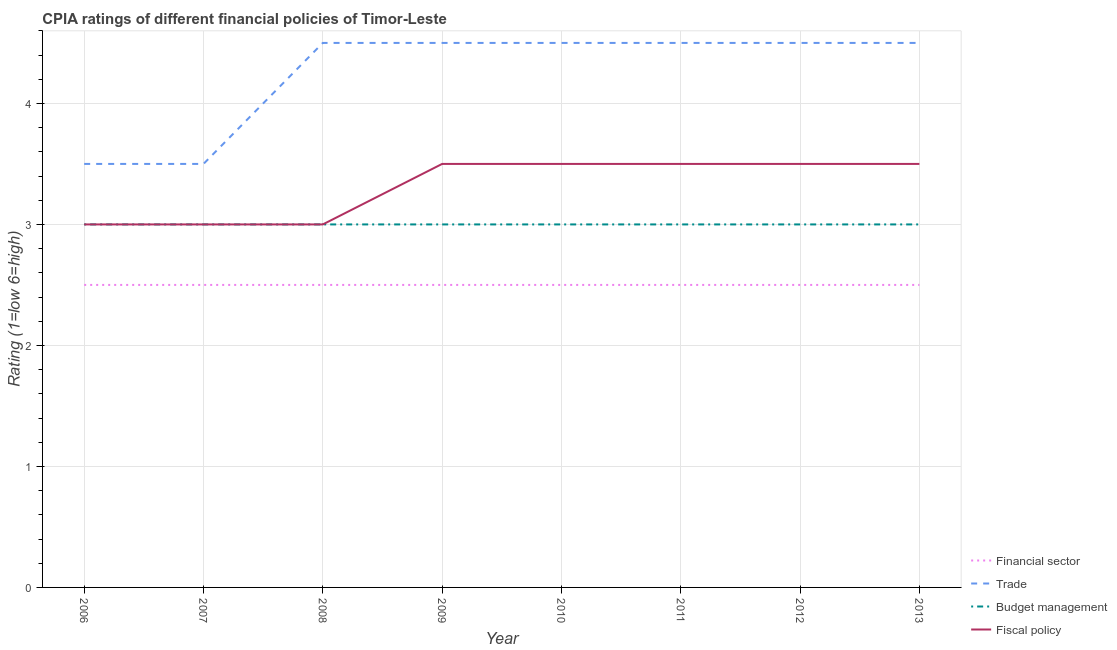How many different coloured lines are there?
Make the answer very short. 4. What is the cpia rating of financial sector in 2013?
Keep it short and to the point. 2.5. Across all years, what is the maximum cpia rating of budget management?
Your response must be concise. 3. Across all years, what is the minimum cpia rating of trade?
Your response must be concise. 3.5. In which year was the cpia rating of fiscal policy minimum?
Your answer should be very brief. 2006. What is the total cpia rating of financial sector in the graph?
Provide a succinct answer. 20. What is the average cpia rating of trade per year?
Offer a very short reply. 4.25. In the year 2012, what is the difference between the cpia rating of budget management and cpia rating of trade?
Offer a terse response. -1.5. What is the ratio of the cpia rating of budget management in 2008 to that in 2009?
Ensure brevity in your answer.  1. Is the cpia rating of financial sector in 2010 less than that in 2012?
Keep it short and to the point. No. Is the difference between the cpia rating of fiscal policy in 2006 and 2012 greater than the difference between the cpia rating of financial sector in 2006 and 2012?
Your answer should be compact. No. In how many years, is the cpia rating of financial sector greater than the average cpia rating of financial sector taken over all years?
Offer a terse response. 0. Is the sum of the cpia rating of budget management in 2008 and 2013 greater than the maximum cpia rating of financial sector across all years?
Your response must be concise. Yes. Is it the case that in every year, the sum of the cpia rating of budget management and cpia rating of financial sector is greater than the sum of cpia rating of trade and cpia rating of fiscal policy?
Make the answer very short. Yes. Does the cpia rating of budget management monotonically increase over the years?
Provide a succinct answer. No. Is the cpia rating of financial sector strictly less than the cpia rating of budget management over the years?
Ensure brevity in your answer.  Yes. How many lines are there?
Provide a succinct answer. 4. What is the difference between two consecutive major ticks on the Y-axis?
Your answer should be very brief. 1. Are the values on the major ticks of Y-axis written in scientific E-notation?
Your response must be concise. No. Does the graph contain grids?
Offer a terse response. Yes. How are the legend labels stacked?
Keep it short and to the point. Vertical. What is the title of the graph?
Ensure brevity in your answer.  CPIA ratings of different financial policies of Timor-Leste. What is the label or title of the X-axis?
Offer a terse response. Year. What is the Rating (1=low 6=high) in Budget management in 2007?
Offer a terse response. 3. What is the Rating (1=low 6=high) of Fiscal policy in 2007?
Keep it short and to the point. 3. What is the Rating (1=low 6=high) in Financial sector in 2008?
Make the answer very short. 2.5. What is the Rating (1=low 6=high) of Budget management in 2008?
Provide a short and direct response. 3. What is the Rating (1=low 6=high) in Financial sector in 2009?
Make the answer very short. 2.5. What is the Rating (1=low 6=high) in Budget management in 2009?
Your answer should be compact. 3. What is the Rating (1=low 6=high) in Fiscal policy in 2009?
Make the answer very short. 3.5. What is the Rating (1=low 6=high) in Fiscal policy in 2010?
Your answer should be compact. 3.5. What is the Rating (1=low 6=high) in Financial sector in 2011?
Offer a terse response. 2.5. What is the Rating (1=low 6=high) in Trade in 2011?
Your answer should be compact. 4.5. What is the Rating (1=low 6=high) of Fiscal policy in 2011?
Your response must be concise. 3.5. What is the Rating (1=low 6=high) in Financial sector in 2012?
Keep it short and to the point. 2.5. What is the Rating (1=low 6=high) in Trade in 2012?
Give a very brief answer. 4.5. What is the Rating (1=low 6=high) of Fiscal policy in 2012?
Your answer should be compact. 3.5. What is the Rating (1=low 6=high) of Budget management in 2013?
Give a very brief answer. 3. Across all years, what is the maximum Rating (1=low 6=high) of Financial sector?
Ensure brevity in your answer.  2.5. Across all years, what is the maximum Rating (1=low 6=high) in Budget management?
Offer a very short reply. 3. Across all years, what is the maximum Rating (1=low 6=high) of Fiscal policy?
Offer a very short reply. 3.5. Across all years, what is the minimum Rating (1=low 6=high) in Trade?
Make the answer very short. 3.5. Across all years, what is the minimum Rating (1=low 6=high) of Budget management?
Keep it short and to the point. 3. What is the total Rating (1=low 6=high) of Budget management in the graph?
Offer a very short reply. 24. What is the total Rating (1=low 6=high) of Fiscal policy in the graph?
Provide a short and direct response. 26.5. What is the difference between the Rating (1=low 6=high) in Trade in 2006 and that in 2007?
Provide a short and direct response. 0. What is the difference between the Rating (1=low 6=high) in Budget management in 2006 and that in 2007?
Make the answer very short. 0. What is the difference between the Rating (1=low 6=high) of Trade in 2006 and that in 2008?
Keep it short and to the point. -1. What is the difference between the Rating (1=low 6=high) in Budget management in 2006 and that in 2008?
Your answer should be compact. 0. What is the difference between the Rating (1=low 6=high) in Financial sector in 2006 and that in 2009?
Give a very brief answer. 0. What is the difference between the Rating (1=low 6=high) in Trade in 2006 and that in 2009?
Your response must be concise. -1. What is the difference between the Rating (1=low 6=high) of Budget management in 2006 and that in 2010?
Ensure brevity in your answer.  0. What is the difference between the Rating (1=low 6=high) in Fiscal policy in 2006 and that in 2010?
Your response must be concise. -0.5. What is the difference between the Rating (1=low 6=high) of Financial sector in 2006 and that in 2011?
Ensure brevity in your answer.  0. What is the difference between the Rating (1=low 6=high) of Financial sector in 2006 and that in 2012?
Offer a very short reply. 0. What is the difference between the Rating (1=low 6=high) in Budget management in 2006 and that in 2012?
Give a very brief answer. 0. What is the difference between the Rating (1=low 6=high) in Fiscal policy in 2006 and that in 2012?
Offer a very short reply. -0.5. What is the difference between the Rating (1=low 6=high) in Financial sector in 2006 and that in 2013?
Make the answer very short. 0. What is the difference between the Rating (1=low 6=high) in Budget management in 2006 and that in 2013?
Your response must be concise. 0. What is the difference between the Rating (1=low 6=high) of Financial sector in 2007 and that in 2008?
Keep it short and to the point. 0. What is the difference between the Rating (1=low 6=high) in Trade in 2007 and that in 2008?
Keep it short and to the point. -1. What is the difference between the Rating (1=low 6=high) of Budget management in 2007 and that in 2009?
Give a very brief answer. 0. What is the difference between the Rating (1=low 6=high) in Financial sector in 2007 and that in 2010?
Your response must be concise. 0. What is the difference between the Rating (1=low 6=high) of Fiscal policy in 2007 and that in 2010?
Ensure brevity in your answer.  -0.5. What is the difference between the Rating (1=low 6=high) of Trade in 2007 and that in 2011?
Provide a succinct answer. -1. What is the difference between the Rating (1=low 6=high) in Budget management in 2007 and that in 2011?
Keep it short and to the point. 0. What is the difference between the Rating (1=low 6=high) of Budget management in 2007 and that in 2012?
Your answer should be compact. 0. What is the difference between the Rating (1=low 6=high) in Fiscal policy in 2007 and that in 2012?
Offer a terse response. -0.5. What is the difference between the Rating (1=low 6=high) of Financial sector in 2007 and that in 2013?
Ensure brevity in your answer.  0. What is the difference between the Rating (1=low 6=high) in Trade in 2007 and that in 2013?
Your answer should be very brief. -1. What is the difference between the Rating (1=low 6=high) in Budget management in 2007 and that in 2013?
Your answer should be compact. 0. What is the difference between the Rating (1=low 6=high) in Financial sector in 2008 and that in 2009?
Provide a short and direct response. 0. What is the difference between the Rating (1=low 6=high) in Trade in 2008 and that in 2009?
Your response must be concise. 0. What is the difference between the Rating (1=low 6=high) in Financial sector in 2008 and that in 2010?
Your answer should be very brief. 0. What is the difference between the Rating (1=low 6=high) in Fiscal policy in 2008 and that in 2010?
Your answer should be compact. -0.5. What is the difference between the Rating (1=low 6=high) in Budget management in 2008 and that in 2011?
Provide a succinct answer. 0. What is the difference between the Rating (1=low 6=high) of Fiscal policy in 2008 and that in 2011?
Provide a succinct answer. -0.5. What is the difference between the Rating (1=low 6=high) in Financial sector in 2008 and that in 2012?
Your response must be concise. 0. What is the difference between the Rating (1=low 6=high) of Trade in 2008 and that in 2012?
Your answer should be very brief. 0. What is the difference between the Rating (1=low 6=high) in Financial sector in 2009 and that in 2010?
Offer a terse response. 0. What is the difference between the Rating (1=low 6=high) of Fiscal policy in 2009 and that in 2010?
Offer a terse response. 0. What is the difference between the Rating (1=low 6=high) in Financial sector in 2009 and that in 2011?
Make the answer very short. 0. What is the difference between the Rating (1=low 6=high) in Budget management in 2009 and that in 2011?
Provide a short and direct response. 0. What is the difference between the Rating (1=low 6=high) in Fiscal policy in 2009 and that in 2011?
Your response must be concise. 0. What is the difference between the Rating (1=low 6=high) of Financial sector in 2009 and that in 2012?
Give a very brief answer. 0. What is the difference between the Rating (1=low 6=high) of Budget management in 2009 and that in 2012?
Your response must be concise. 0. What is the difference between the Rating (1=low 6=high) of Trade in 2009 and that in 2013?
Provide a succinct answer. 0. What is the difference between the Rating (1=low 6=high) of Fiscal policy in 2009 and that in 2013?
Your answer should be compact. 0. What is the difference between the Rating (1=low 6=high) of Trade in 2010 and that in 2011?
Provide a short and direct response. 0. What is the difference between the Rating (1=low 6=high) in Budget management in 2010 and that in 2011?
Offer a terse response. 0. What is the difference between the Rating (1=low 6=high) in Financial sector in 2010 and that in 2012?
Make the answer very short. 0. What is the difference between the Rating (1=low 6=high) of Budget management in 2010 and that in 2012?
Provide a short and direct response. 0. What is the difference between the Rating (1=low 6=high) in Fiscal policy in 2010 and that in 2012?
Your answer should be compact. 0. What is the difference between the Rating (1=low 6=high) in Fiscal policy in 2010 and that in 2013?
Your response must be concise. 0. What is the difference between the Rating (1=low 6=high) in Financial sector in 2011 and that in 2012?
Offer a very short reply. 0. What is the difference between the Rating (1=low 6=high) in Trade in 2011 and that in 2013?
Make the answer very short. 0. What is the difference between the Rating (1=low 6=high) of Budget management in 2011 and that in 2013?
Provide a succinct answer. 0. What is the difference between the Rating (1=low 6=high) in Trade in 2012 and that in 2013?
Your answer should be very brief. 0. What is the difference between the Rating (1=low 6=high) in Fiscal policy in 2012 and that in 2013?
Your answer should be very brief. 0. What is the difference between the Rating (1=low 6=high) of Financial sector in 2006 and the Rating (1=low 6=high) of Trade in 2007?
Keep it short and to the point. -1. What is the difference between the Rating (1=low 6=high) of Financial sector in 2006 and the Rating (1=low 6=high) of Budget management in 2007?
Keep it short and to the point. -0.5. What is the difference between the Rating (1=low 6=high) in Financial sector in 2006 and the Rating (1=low 6=high) in Fiscal policy in 2007?
Offer a very short reply. -0.5. What is the difference between the Rating (1=low 6=high) of Trade in 2006 and the Rating (1=low 6=high) of Budget management in 2007?
Your answer should be compact. 0.5. What is the difference between the Rating (1=low 6=high) in Trade in 2006 and the Rating (1=low 6=high) in Fiscal policy in 2007?
Offer a terse response. 0.5. What is the difference between the Rating (1=low 6=high) in Budget management in 2006 and the Rating (1=low 6=high) in Fiscal policy in 2007?
Give a very brief answer. 0. What is the difference between the Rating (1=low 6=high) in Financial sector in 2006 and the Rating (1=low 6=high) in Trade in 2008?
Your answer should be compact. -2. What is the difference between the Rating (1=low 6=high) in Financial sector in 2006 and the Rating (1=low 6=high) in Budget management in 2008?
Offer a very short reply. -0.5. What is the difference between the Rating (1=low 6=high) in Trade in 2006 and the Rating (1=low 6=high) in Budget management in 2008?
Ensure brevity in your answer.  0.5. What is the difference between the Rating (1=low 6=high) of Financial sector in 2006 and the Rating (1=low 6=high) of Trade in 2009?
Keep it short and to the point. -2. What is the difference between the Rating (1=low 6=high) in Financial sector in 2006 and the Rating (1=low 6=high) in Fiscal policy in 2009?
Your response must be concise. -1. What is the difference between the Rating (1=low 6=high) in Trade in 2006 and the Rating (1=low 6=high) in Budget management in 2009?
Your answer should be very brief. 0.5. What is the difference between the Rating (1=low 6=high) of Trade in 2006 and the Rating (1=low 6=high) of Fiscal policy in 2009?
Your response must be concise. 0. What is the difference between the Rating (1=low 6=high) of Financial sector in 2006 and the Rating (1=low 6=high) of Budget management in 2010?
Your response must be concise. -0.5. What is the difference between the Rating (1=low 6=high) in Financial sector in 2006 and the Rating (1=low 6=high) in Fiscal policy in 2010?
Your answer should be compact. -1. What is the difference between the Rating (1=low 6=high) in Trade in 2006 and the Rating (1=low 6=high) in Budget management in 2010?
Provide a succinct answer. 0.5. What is the difference between the Rating (1=low 6=high) in Financial sector in 2006 and the Rating (1=low 6=high) in Fiscal policy in 2011?
Your answer should be compact. -1. What is the difference between the Rating (1=low 6=high) in Trade in 2006 and the Rating (1=low 6=high) in Budget management in 2011?
Make the answer very short. 0.5. What is the difference between the Rating (1=low 6=high) of Financial sector in 2006 and the Rating (1=low 6=high) of Budget management in 2012?
Provide a succinct answer. -0.5. What is the difference between the Rating (1=low 6=high) of Financial sector in 2006 and the Rating (1=low 6=high) of Fiscal policy in 2012?
Give a very brief answer. -1. What is the difference between the Rating (1=low 6=high) of Trade in 2006 and the Rating (1=low 6=high) of Fiscal policy in 2012?
Give a very brief answer. 0. What is the difference between the Rating (1=low 6=high) of Financial sector in 2006 and the Rating (1=low 6=high) of Budget management in 2013?
Your answer should be very brief. -0.5. What is the difference between the Rating (1=low 6=high) of Trade in 2006 and the Rating (1=low 6=high) of Budget management in 2013?
Keep it short and to the point. 0.5. What is the difference between the Rating (1=low 6=high) in Budget management in 2006 and the Rating (1=low 6=high) in Fiscal policy in 2013?
Keep it short and to the point. -0.5. What is the difference between the Rating (1=low 6=high) of Financial sector in 2007 and the Rating (1=low 6=high) of Trade in 2008?
Provide a short and direct response. -2. What is the difference between the Rating (1=low 6=high) in Trade in 2007 and the Rating (1=low 6=high) in Budget management in 2008?
Your answer should be very brief. 0.5. What is the difference between the Rating (1=low 6=high) in Financial sector in 2007 and the Rating (1=low 6=high) in Trade in 2009?
Offer a terse response. -2. What is the difference between the Rating (1=low 6=high) of Financial sector in 2007 and the Rating (1=low 6=high) of Budget management in 2009?
Offer a terse response. -0.5. What is the difference between the Rating (1=low 6=high) in Trade in 2007 and the Rating (1=low 6=high) in Fiscal policy in 2009?
Provide a short and direct response. 0. What is the difference between the Rating (1=low 6=high) of Budget management in 2007 and the Rating (1=low 6=high) of Fiscal policy in 2009?
Ensure brevity in your answer.  -0.5. What is the difference between the Rating (1=low 6=high) of Financial sector in 2007 and the Rating (1=low 6=high) of Budget management in 2010?
Make the answer very short. -0.5. What is the difference between the Rating (1=low 6=high) in Financial sector in 2007 and the Rating (1=low 6=high) in Fiscal policy in 2010?
Your answer should be compact. -1. What is the difference between the Rating (1=low 6=high) in Trade in 2007 and the Rating (1=low 6=high) in Budget management in 2010?
Make the answer very short. 0.5. What is the difference between the Rating (1=low 6=high) of Trade in 2007 and the Rating (1=low 6=high) of Fiscal policy in 2010?
Ensure brevity in your answer.  0. What is the difference between the Rating (1=low 6=high) of Budget management in 2007 and the Rating (1=low 6=high) of Fiscal policy in 2010?
Ensure brevity in your answer.  -0.5. What is the difference between the Rating (1=low 6=high) of Financial sector in 2007 and the Rating (1=low 6=high) of Budget management in 2011?
Give a very brief answer. -0.5. What is the difference between the Rating (1=low 6=high) in Trade in 2007 and the Rating (1=low 6=high) in Fiscal policy in 2011?
Keep it short and to the point. 0. What is the difference between the Rating (1=low 6=high) in Budget management in 2007 and the Rating (1=low 6=high) in Fiscal policy in 2011?
Ensure brevity in your answer.  -0.5. What is the difference between the Rating (1=low 6=high) in Financial sector in 2007 and the Rating (1=low 6=high) in Trade in 2012?
Your answer should be very brief. -2. What is the difference between the Rating (1=low 6=high) of Financial sector in 2007 and the Rating (1=low 6=high) of Budget management in 2012?
Offer a very short reply. -0.5. What is the difference between the Rating (1=low 6=high) of Financial sector in 2007 and the Rating (1=low 6=high) of Fiscal policy in 2012?
Your response must be concise. -1. What is the difference between the Rating (1=low 6=high) of Trade in 2007 and the Rating (1=low 6=high) of Budget management in 2012?
Offer a terse response. 0.5. What is the difference between the Rating (1=low 6=high) of Trade in 2007 and the Rating (1=low 6=high) of Fiscal policy in 2012?
Your response must be concise. 0. What is the difference between the Rating (1=low 6=high) in Financial sector in 2007 and the Rating (1=low 6=high) in Budget management in 2013?
Offer a terse response. -0.5. What is the difference between the Rating (1=low 6=high) of Financial sector in 2007 and the Rating (1=low 6=high) of Fiscal policy in 2013?
Keep it short and to the point. -1. What is the difference between the Rating (1=low 6=high) in Trade in 2007 and the Rating (1=low 6=high) in Budget management in 2013?
Make the answer very short. 0.5. What is the difference between the Rating (1=low 6=high) in Budget management in 2007 and the Rating (1=low 6=high) in Fiscal policy in 2013?
Provide a succinct answer. -0.5. What is the difference between the Rating (1=low 6=high) of Financial sector in 2008 and the Rating (1=low 6=high) of Fiscal policy in 2009?
Ensure brevity in your answer.  -1. What is the difference between the Rating (1=low 6=high) of Trade in 2008 and the Rating (1=low 6=high) of Fiscal policy in 2009?
Your answer should be compact. 1. What is the difference between the Rating (1=low 6=high) of Budget management in 2008 and the Rating (1=low 6=high) of Fiscal policy in 2009?
Your response must be concise. -0.5. What is the difference between the Rating (1=low 6=high) of Financial sector in 2008 and the Rating (1=low 6=high) of Trade in 2010?
Keep it short and to the point. -2. What is the difference between the Rating (1=low 6=high) in Financial sector in 2008 and the Rating (1=low 6=high) in Budget management in 2010?
Keep it short and to the point. -0.5. What is the difference between the Rating (1=low 6=high) of Trade in 2008 and the Rating (1=low 6=high) of Budget management in 2010?
Offer a terse response. 1.5. What is the difference between the Rating (1=low 6=high) of Budget management in 2008 and the Rating (1=low 6=high) of Fiscal policy in 2010?
Provide a succinct answer. -0.5. What is the difference between the Rating (1=low 6=high) in Financial sector in 2008 and the Rating (1=low 6=high) in Fiscal policy in 2011?
Make the answer very short. -1. What is the difference between the Rating (1=low 6=high) of Trade in 2008 and the Rating (1=low 6=high) of Budget management in 2011?
Provide a succinct answer. 1.5. What is the difference between the Rating (1=low 6=high) in Trade in 2008 and the Rating (1=low 6=high) in Fiscal policy in 2011?
Offer a terse response. 1. What is the difference between the Rating (1=low 6=high) in Financial sector in 2008 and the Rating (1=low 6=high) in Budget management in 2012?
Keep it short and to the point. -0.5. What is the difference between the Rating (1=low 6=high) in Financial sector in 2008 and the Rating (1=low 6=high) in Trade in 2013?
Provide a short and direct response. -2. What is the difference between the Rating (1=low 6=high) in Financial sector in 2008 and the Rating (1=low 6=high) in Fiscal policy in 2013?
Your answer should be compact. -1. What is the difference between the Rating (1=low 6=high) of Trade in 2008 and the Rating (1=low 6=high) of Budget management in 2013?
Make the answer very short. 1.5. What is the difference between the Rating (1=low 6=high) of Trade in 2008 and the Rating (1=low 6=high) of Fiscal policy in 2013?
Your response must be concise. 1. What is the difference between the Rating (1=low 6=high) of Budget management in 2008 and the Rating (1=low 6=high) of Fiscal policy in 2013?
Your answer should be very brief. -0.5. What is the difference between the Rating (1=low 6=high) in Financial sector in 2009 and the Rating (1=low 6=high) in Trade in 2010?
Offer a very short reply. -2. What is the difference between the Rating (1=low 6=high) in Financial sector in 2009 and the Rating (1=low 6=high) in Budget management in 2010?
Ensure brevity in your answer.  -0.5. What is the difference between the Rating (1=low 6=high) of Financial sector in 2009 and the Rating (1=low 6=high) of Fiscal policy in 2010?
Your response must be concise. -1. What is the difference between the Rating (1=low 6=high) in Trade in 2009 and the Rating (1=low 6=high) in Fiscal policy in 2010?
Offer a very short reply. 1. What is the difference between the Rating (1=low 6=high) of Financial sector in 2009 and the Rating (1=low 6=high) of Trade in 2011?
Your answer should be compact. -2. What is the difference between the Rating (1=low 6=high) of Trade in 2009 and the Rating (1=low 6=high) of Budget management in 2011?
Offer a very short reply. 1.5. What is the difference between the Rating (1=low 6=high) in Budget management in 2009 and the Rating (1=low 6=high) in Fiscal policy in 2011?
Make the answer very short. -0.5. What is the difference between the Rating (1=low 6=high) in Financial sector in 2009 and the Rating (1=low 6=high) in Budget management in 2012?
Offer a very short reply. -0.5. What is the difference between the Rating (1=low 6=high) of Financial sector in 2009 and the Rating (1=low 6=high) of Trade in 2013?
Your answer should be very brief. -2. What is the difference between the Rating (1=low 6=high) in Financial sector in 2009 and the Rating (1=low 6=high) in Fiscal policy in 2013?
Keep it short and to the point. -1. What is the difference between the Rating (1=low 6=high) in Trade in 2009 and the Rating (1=low 6=high) in Fiscal policy in 2013?
Provide a succinct answer. 1. What is the difference between the Rating (1=low 6=high) in Budget management in 2009 and the Rating (1=low 6=high) in Fiscal policy in 2013?
Provide a succinct answer. -0.5. What is the difference between the Rating (1=low 6=high) of Financial sector in 2010 and the Rating (1=low 6=high) of Trade in 2011?
Your answer should be very brief. -2. What is the difference between the Rating (1=low 6=high) of Financial sector in 2010 and the Rating (1=low 6=high) of Budget management in 2011?
Your response must be concise. -0.5. What is the difference between the Rating (1=low 6=high) in Trade in 2010 and the Rating (1=low 6=high) in Budget management in 2011?
Make the answer very short. 1.5. What is the difference between the Rating (1=low 6=high) of Financial sector in 2010 and the Rating (1=low 6=high) of Budget management in 2012?
Your answer should be compact. -0.5. What is the difference between the Rating (1=low 6=high) of Financial sector in 2010 and the Rating (1=low 6=high) of Fiscal policy in 2012?
Make the answer very short. -1. What is the difference between the Rating (1=low 6=high) in Trade in 2010 and the Rating (1=low 6=high) in Fiscal policy in 2012?
Provide a succinct answer. 1. What is the difference between the Rating (1=low 6=high) of Budget management in 2010 and the Rating (1=low 6=high) of Fiscal policy in 2012?
Ensure brevity in your answer.  -0.5. What is the difference between the Rating (1=low 6=high) of Financial sector in 2010 and the Rating (1=low 6=high) of Trade in 2013?
Ensure brevity in your answer.  -2. What is the difference between the Rating (1=low 6=high) in Trade in 2010 and the Rating (1=low 6=high) in Budget management in 2013?
Keep it short and to the point. 1.5. What is the difference between the Rating (1=low 6=high) in Financial sector in 2011 and the Rating (1=low 6=high) in Trade in 2012?
Offer a very short reply. -2. What is the difference between the Rating (1=low 6=high) of Financial sector in 2011 and the Rating (1=low 6=high) of Budget management in 2012?
Provide a short and direct response. -0.5. What is the difference between the Rating (1=low 6=high) of Financial sector in 2011 and the Rating (1=low 6=high) of Fiscal policy in 2012?
Your answer should be compact. -1. What is the difference between the Rating (1=low 6=high) in Financial sector in 2011 and the Rating (1=low 6=high) in Budget management in 2013?
Provide a succinct answer. -0.5. What is the difference between the Rating (1=low 6=high) in Trade in 2011 and the Rating (1=low 6=high) in Budget management in 2013?
Offer a terse response. 1.5. What is the difference between the Rating (1=low 6=high) of Budget management in 2011 and the Rating (1=low 6=high) of Fiscal policy in 2013?
Provide a short and direct response. -0.5. What is the difference between the Rating (1=low 6=high) of Financial sector in 2012 and the Rating (1=low 6=high) of Trade in 2013?
Your answer should be very brief. -2. What is the difference between the Rating (1=low 6=high) in Trade in 2012 and the Rating (1=low 6=high) in Budget management in 2013?
Your answer should be compact. 1.5. What is the difference between the Rating (1=low 6=high) in Budget management in 2012 and the Rating (1=low 6=high) in Fiscal policy in 2013?
Ensure brevity in your answer.  -0.5. What is the average Rating (1=low 6=high) in Trade per year?
Give a very brief answer. 4.25. What is the average Rating (1=low 6=high) of Budget management per year?
Make the answer very short. 3. What is the average Rating (1=low 6=high) in Fiscal policy per year?
Give a very brief answer. 3.31. In the year 2006, what is the difference between the Rating (1=low 6=high) of Financial sector and Rating (1=low 6=high) of Fiscal policy?
Ensure brevity in your answer.  -0.5. In the year 2006, what is the difference between the Rating (1=low 6=high) of Trade and Rating (1=low 6=high) of Budget management?
Give a very brief answer. 0.5. In the year 2006, what is the difference between the Rating (1=low 6=high) in Budget management and Rating (1=low 6=high) in Fiscal policy?
Your answer should be compact. 0. In the year 2007, what is the difference between the Rating (1=low 6=high) of Financial sector and Rating (1=low 6=high) of Trade?
Offer a very short reply. -1. In the year 2007, what is the difference between the Rating (1=low 6=high) of Financial sector and Rating (1=low 6=high) of Budget management?
Keep it short and to the point. -0.5. In the year 2007, what is the difference between the Rating (1=low 6=high) in Budget management and Rating (1=low 6=high) in Fiscal policy?
Ensure brevity in your answer.  0. In the year 2008, what is the difference between the Rating (1=low 6=high) in Financial sector and Rating (1=low 6=high) in Trade?
Make the answer very short. -2. In the year 2008, what is the difference between the Rating (1=low 6=high) in Trade and Rating (1=low 6=high) in Fiscal policy?
Keep it short and to the point. 1.5. In the year 2008, what is the difference between the Rating (1=low 6=high) in Budget management and Rating (1=low 6=high) in Fiscal policy?
Your answer should be very brief. 0. In the year 2009, what is the difference between the Rating (1=low 6=high) in Financial sector and Rating (1=low 6=high) in Fiscal policy?
Offer a very short reply. -1. In the year 2009, what is the difference between the Rating (1=low 6=high) in Trade and Rating (1=low 6=high) in Fiscal policy?
Offer a terse response. 1. In the year 2009, what is the difference between the Rating (1=low 6=high) in Budget management and Rating (1=low 6=high) in Fiscal policy?
Offer a terse response. -0.5. In the year 2010, what is the difference between the Rating (1=low 6=high) in Trade and Rating (1=low 6=high) in Budget management?
Your answer should be compact. 1.5. In the year 2010, what is the difference between the Rating (1=low 6=high) of Trade and Rating (1=low 6=high) of Fiscal policy?
Ensure brevity in your answer.  1. In the year 2011, what is the difference between the Rating (1=low 6=high) of Financial sector and Rating (1=low 6=high) of Budget management?
Your answer should be very brief. -0.5. In the year 2011, what is the difference between the Rating (1=low 6=high) in Financial sector and Rating (1=low 6=high) in Fiscal policy?
Make the answer very short. -1. In the year 2011, what is the difference between the Rating (1=low 6=high) of Trade and Rating (1=low 6=high) of Budget management?
Give a very brief answer. 1.5. In the year 2012, what is the difference between the Rating (1=low 6=high) of Financial sector and Rating (1=low 6=high) of Fiscal policy?
Your answer should be very brief. -1. In the year 2012, what is the difference between the Rating (1=low 6=high) of Trade and Rating (1=low 6=high) of Budget management?
Your answer should be very brief. 1.5. In the year 2012, what is the difference between the Rating (1=low 6=high) of Trade and Rating (1=low 6=high) of Fiscal policy?
Provide a short and direct response. 1. In the year 2013, what is the difference between the Rating (1=low 6=high) of Trade and Rating (1=low 6=high) of Budget management?
Make the answer very short. 1.5. In the year 2013, what is the difference between the Rating (1=low 6=high) of Trade and Rating (1=low 6=high) of Fiscal policy?
Offer a terse response. 1. In the year 2013, what is the difference between the Rating (1=low 6=high) of Budget management and Rating (1=low 6=high) of Fiscal policy?
Offer a terse response. -0.5. What is the ratio of the Rating (1=low 6=high) of Trade in 2006 to that in 2007?
Provide a short and direct response. 1. What is the ratio of the Rating (1=low 6=high) of Fiscal policy in 2006 to that in 2007?
Offer a very short reply. 1. What is the ratio of the Rating (1=low 6=high) in Trade in 2006 to that in 2009?
Provide a short and direct response. 0.78. What is the ratio of the Rating (1=low 6=high) in Budget management in 2006 to that in 2009?
Provide a short and direct response. 1. What is the ratio of the Rating (1=low 6=high) of Fiscal policy in 2006 to that in 2009?
Provide a short and direct response. 0.86. What is the ratio of the Rating (1=low 6=high) of Financial sector in 2006 to that in 2010?
Your answer should be very brief. 1. What is the ratio of the Rating (1=low 6=high) of Trade in 2006 to that in 2010?
Offer a very short reply. 0.78. What is the ratio of the Rating (1=low 6=high) in Budget management in 2006 to that in 2010?
Offer a terse response. 1. What is the ratio of the Rating (1=low 6=high) in Fiscal policy in 2006 to that in 2010?
Keep it short and to the point. 0.86. What is the ratio of the Rating (1=low 6=high) of Financial sector in 2006 to that in 2011?
Offer a terse response. 1. What is the ratio of the Rating (1=low 6=high) of Trade in 2006 to that in 2011?
Provide a short and direct response. 0.78. What is the ratio of the Rating (1=low 6=high) of Budget management in 2006 to that in 2011?
Your response must be concise. 1. What is the ratio of the Rating (1=low 6=high) in Budget management in 2006 to that in 2012?
Offer a terse response. 1. What is the ratio of the Rating (1=low 6=high) of Fiscal policy in 2006 to that in 2012?
Ensure brevity in your answer.  0.86. What is the ratio of the Rating (1=low 6=high) of Financial sector in 2006 to that in 2013?
Give a very brief answer. 1. What is the ratio of the Rating (1=low 6=high) of Budget management in 2006 to that in 2013?
Provide a short and direct response. 1. What is the ratio of the Rating (1=low 6=high) of Fiscal policy in 2006 to that in 2013?
Provide a succinct answer. 0.86. What is the ratio of the Rating (1=low 6=high) in Financial sector in 2007 to that in 2008?
Keep it short and to the point. 1. What is the ratio of the Rating (1=low 6=high) of Budget management in 2007 to that in 2008?
Offer a very short reply. 1. What is the ratio of the Rating (1=low 6=high) in Fiscal policy in 2007 to that in 2009?
Provide a succinct answer. 0.86. What is the ratio of the Rating (1=low 6=high) of Financial sector in 2007 to that in 2010?
Offer a terse response. 1. What is the ratio of the Rating (1=low 6=high) in Trade in 2007 to that in 2010?
Offer a very short reply. 0.78. What is the ratio of the Rating (1=low 6=high) in Budget management in 2007 to that in 2012?
Give a very brief answer. 1. What is the ratio of the Rating (1=low 6=high) in Financial sector in 2007 to that in 2013?
Your answer should be very brief. 1. What is the ratio of the Rating (1=low 6=high) of Trade in 2007 to that in 2013?
Your answer should be very brief. 0.78. What is the ratio of the Rating (1=low 6=high) in Fiscal policy in 2007 to that in 2013?
Your answer should be very brief. 0.86. What is the ratio of the Rating (1=low 6=high) of Trade in 2008 to that in 2009?
Provide a short and direct response. 1. What is the ratio of the Rating (1=low 6=high) in Budget management in 2008 to that in 2009?
Give a very brief answer. 1. What is the ratio of the Rating (1=low 6=high) in Financial sector in 2008 to that in 2010?
Your answer should be very brief. 1. What is the ratio of the Rating (1=low 6=high) of Fiscal policy in 2008 to that in 2010?
Provide a short and direct response. 0.86. What is the ratio of the Rating (1=low 6=high) in Financial sector in 2008 to that in 2011?
Your response must be concise. 1. What is the ratio of the Rating (1=low 6=high) in Trade in 2008 to that in 2011?
Ensure brevity in your answer.  1. What is the ratio of the Rating (1=low 6=high) of Budget management in 2008 to that in 2011?
Your answer should be very brief. 1. What is the ratio of the Rating (1=low 6=high) in Fiscal policy in 2008 to that in 2011?
Offer a terse response. 0.86. What is the ratio of the Rating (1=low 6=high) in Financial sector in 2008 to that in 2012?
Your answer should be very brief. 1. What is the ratio of the Rating (1=low 6=high) in Trade in 2008 to that in 2012?
Ensure brevity in your answer.  1. What is the ratio of the Rating (1=low 6=high) of Trade in 2008 to that in 2013?
Make the answer very short. 1. What is the ratio of the Rating (1=low 6=high) of Financial sector in 2009 to that in 2011?
Your answer should be compact. 1. What is the ratio of the Rating (1=low 6=high) of Budget management in 2009 to that in 2011?
Keep it short and to the point. 1. What is the ratio of the Rating (1=low 6=high) of Fiscal policy in 2009 to that in 2011?
Provide a short and direct response. 1. What is the ratio of the Rating (1=low 6=high) of Financial sector in 2009 to that in 2012?
Make the answer very short. 1. What is the ratio of the Rating (1=low 6=high) in Trade in 2009 to that in 2012?
Offer a terse response. 1. What is the ratio of the Rating (1=low 6=high) in Budget management in 2009 to that in 2012?
Give a very brief answer. 1. What is the ratio of the Rating (1=low 6=high) in Financial sector in 2009 to that in 2013?
Provide a succinct answer. 1. What is the ratio of the Rating (1=low 6=high) in Trade in 2010 to that in 2011?
Make the answer very short. 1. What is the ratio of the Rating (1=low 6=high) of Budget management in 2010 to that in 2011?
Provide a succinct answer. 1. What is the ratio of the Rating (1=low 6=high) in Fiscal policy in 2010 to that in 2011?
Provide a succinct answer. 1. What is the ratio of the Rating (1=low 6=high) in Budget management in 2010 to that in 2012?
Your response must be concise. 1. What is the ratio of the Rating (1=low 6=high) in Fiscal policy in 2010 to that in 2012?
Offer a very short reply. 1. What is the ratio of the Rating (1=low 6=high) in Financial sector in 2010 to that in 2013?
Give a very brief answer. 1. What is the ratio of the Rating (1=low 6=high) in Trade in 2010 to that in 2013?
Keep it short and to the point. 1. What is the ratio of the Rating (1=low 6=high) in Trade in 2011 to that in 2012?
Ensure brevity in your answer.  1. What is the ratio of the Rating (1=low 6=high) in Budget management in 2011 to that in 2012?
Your response must be concise. 1. What is the ratio of the Rating (1=low 6=high) in Financial sector in 2011 to that in 2013?
Offer a terse response. 1. What is the ratio of the Rating (1=low 6=high) in Budget management in 2011 to that in 2013?
Keep it short and to the point. 1. What is the ratio of the Rating (1=low 6=high) of Fiscal policy in 2011 to that in 2013?
Give a very brief answer. 1. What is the ratio of the Rating (1=low 6=high) of Financial sector in 2012 to that in 2013?
Provide a short and direct response. 1. What is the ratio of the Rating (1=low 6=high) of Trade in 2012 to that in 2013?
Ensure brevity in your answer.  1. What is the difference between the highest and the second highest Rating (1=low 6=high) of Trade?
Ensure brevity in your answer.  0. What is the difference between the highest and the second highest Rating (1=low 6=high) of Fiscal policy?
Provide a succinct answer. 0. What is the difference between the highest and the lowest Rating (1=low 6=high) in Fiscal policy?
Your answer should be very brief. 0.5. 